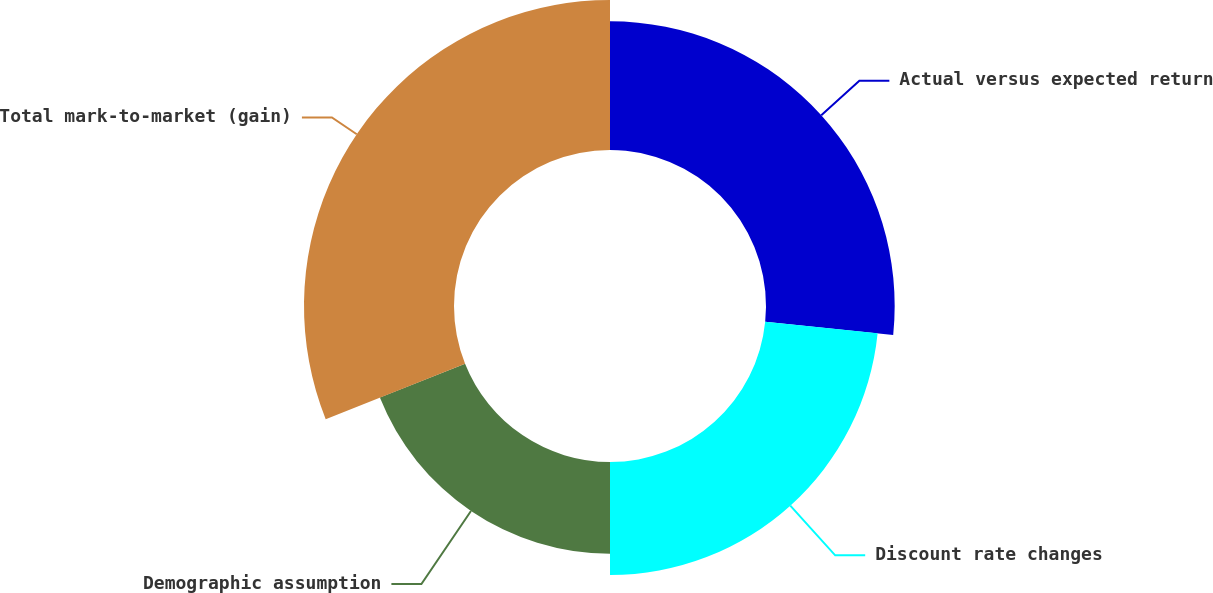Convert chart to OTSL. <chart><loc_0><loc_0><loc_500><loc_500><pie_chart><fcel>Actual versus expected return<fcel>Discount rate changes<fcel>Demographic assumption<fcel>Total mark-to-market (gain)<nl><fcel>26.62%<fcel>23.38%<fcel>18.97%<fcel>31.03%<nl></chart> 